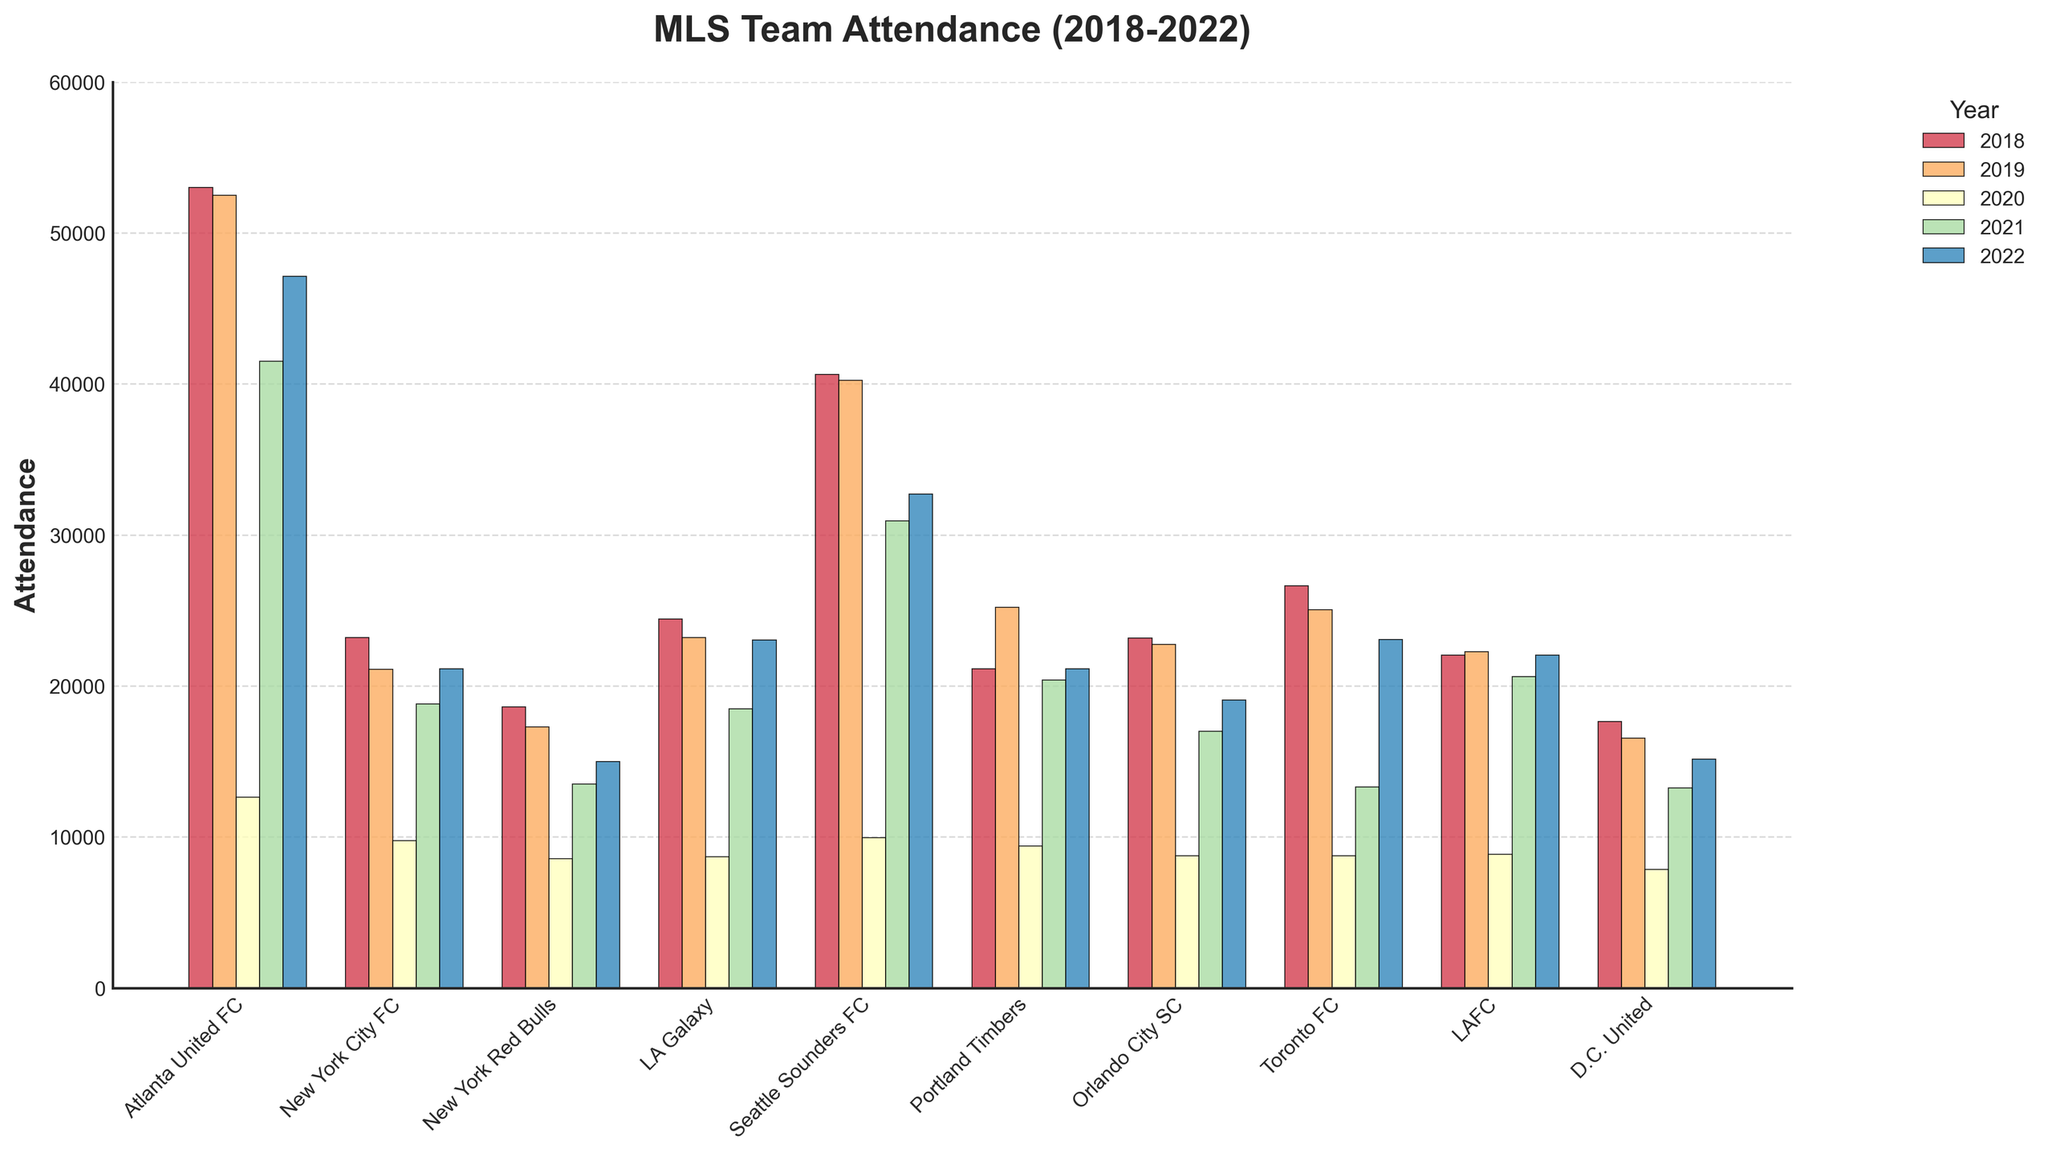Which MLS team had the highest attendance in 2018? Look at the bars representing the year 2018 and find the one with the highest value. Atlanta United FC's bar is the tallest in 2018.
Answer: Atlanta United FC What is the average attendance for Atlanta United FC over the 5 seasons? Atlanta United FC's attendance figures are 53002, 52510, 12623, 41507, and 47116. Sum these values and divide by 5 to get the average: (53002 + 52510 + 12623 + 41507 + 47116) / 5 = 41351.6.
Answer: 41351.6 Which team had a higher attendance in 2022, New York City FC or New York Red Bulls? Compare the heights of the bars corresponding to New York City FC and New York Red Bulls for the year 2022. NYC FC has a higher bar with 21,122, as opposed to the NY Red Bulls with 15,005.
Answer: New York City FC How did the attendance for Seattle Sounders FC change from 2020 to 2021? Compare the bar heights for Seattle Sounders FC for 2020 and 2021. Attendance increased from 9937 in 2020 to 30943 in 2021.
Answer: Increased Did any team have a consistent attendance figure in any two consecutive years? Identify if any team's bars have the same height for two adjacent years. Portland Timbers had an attendance of 21,144 in both 2018 and 2022.
Answer: Portland Timbers Which year had the lowest overall attendance figures across all teams? Sum the attendance figures for all teams per year and identify the year with the lowest total. 2020 has the lowest sum: 12623 + 9751 + 8571 + 8687 + 9937 + 9392 + 8742 + 8742 + 8835 + 7835 = 86115.
Answer: 2020 What was the difference in attendance for LA Galaxy between 2019 and 2021? Subtract the 2021 attendance figure for LA Galaxy from that of 2019: 23205 - 18487 = 4718.
Answer: 4718 Which team had the closest attendance figures in the year 2022? Compare the bar heights for each team in 2022 to find the ones that are most similar. New York City FC (21122) and Portland Timbers (21144) have the closest bars.
Answer: New York City FC and Portland Timbers 